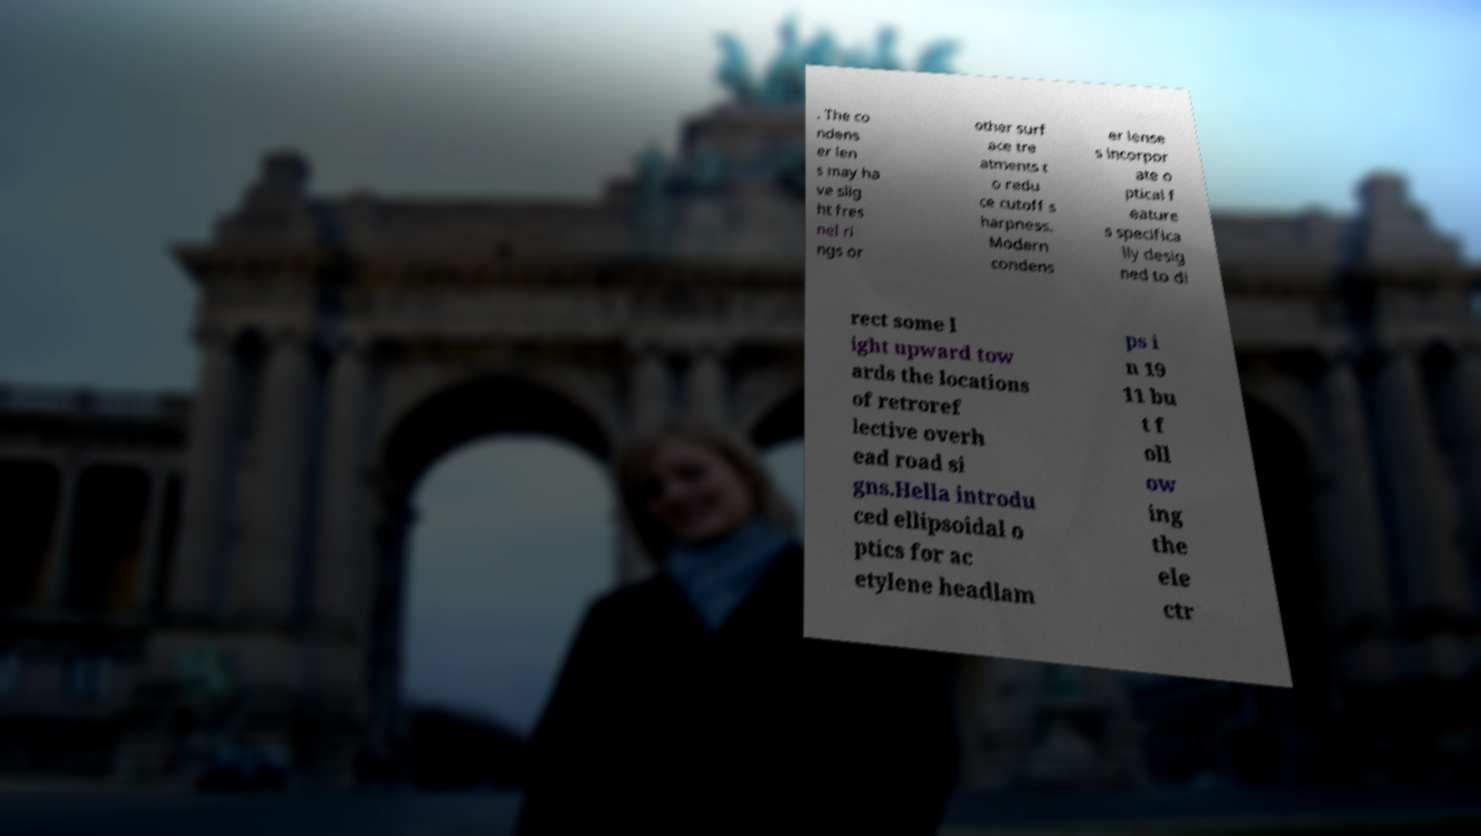Please read and relay the text visible in this image. What does it say? . The co ndens er len s may ha ve slig ht fres nel ri ngs or other surf ace tre atments t o redu ce cutoff s harpness. Modern condens er lense s incorpor ate o ptical f eature s specifica lly desig ned to di rect some l ight upward tow ards the locations of retroref lective overh ead road si gns.Hella introdu ced ellipsoidal o ptics for ac etylene headlam ps i n 19 11 bu t f oll ow ing the ele ctr 